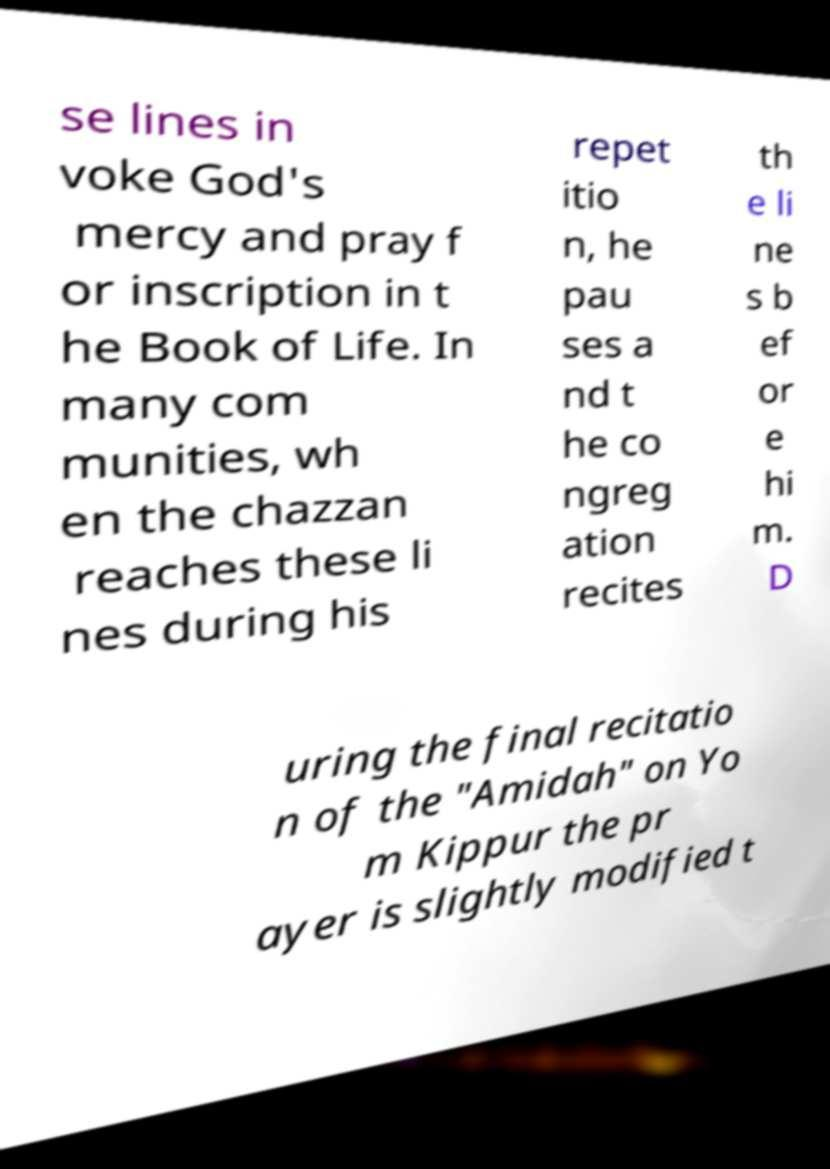Can you read and provide the text displayed in the image?This photo seems to have some interesting text. Can you extract and type it out for me? se lines in voke God's mercy and pray f or inscription in t he Book of Life. In many com munities, wh en the chazzan reaches these li nes during his repet itio n, he pau ses a nd t he co ngreg ation recites th e li ne s b ef or e hi m. D uring the final recitatio n of the "Amidah" on Yo m Kippur the pr ayer is slightly modified t 